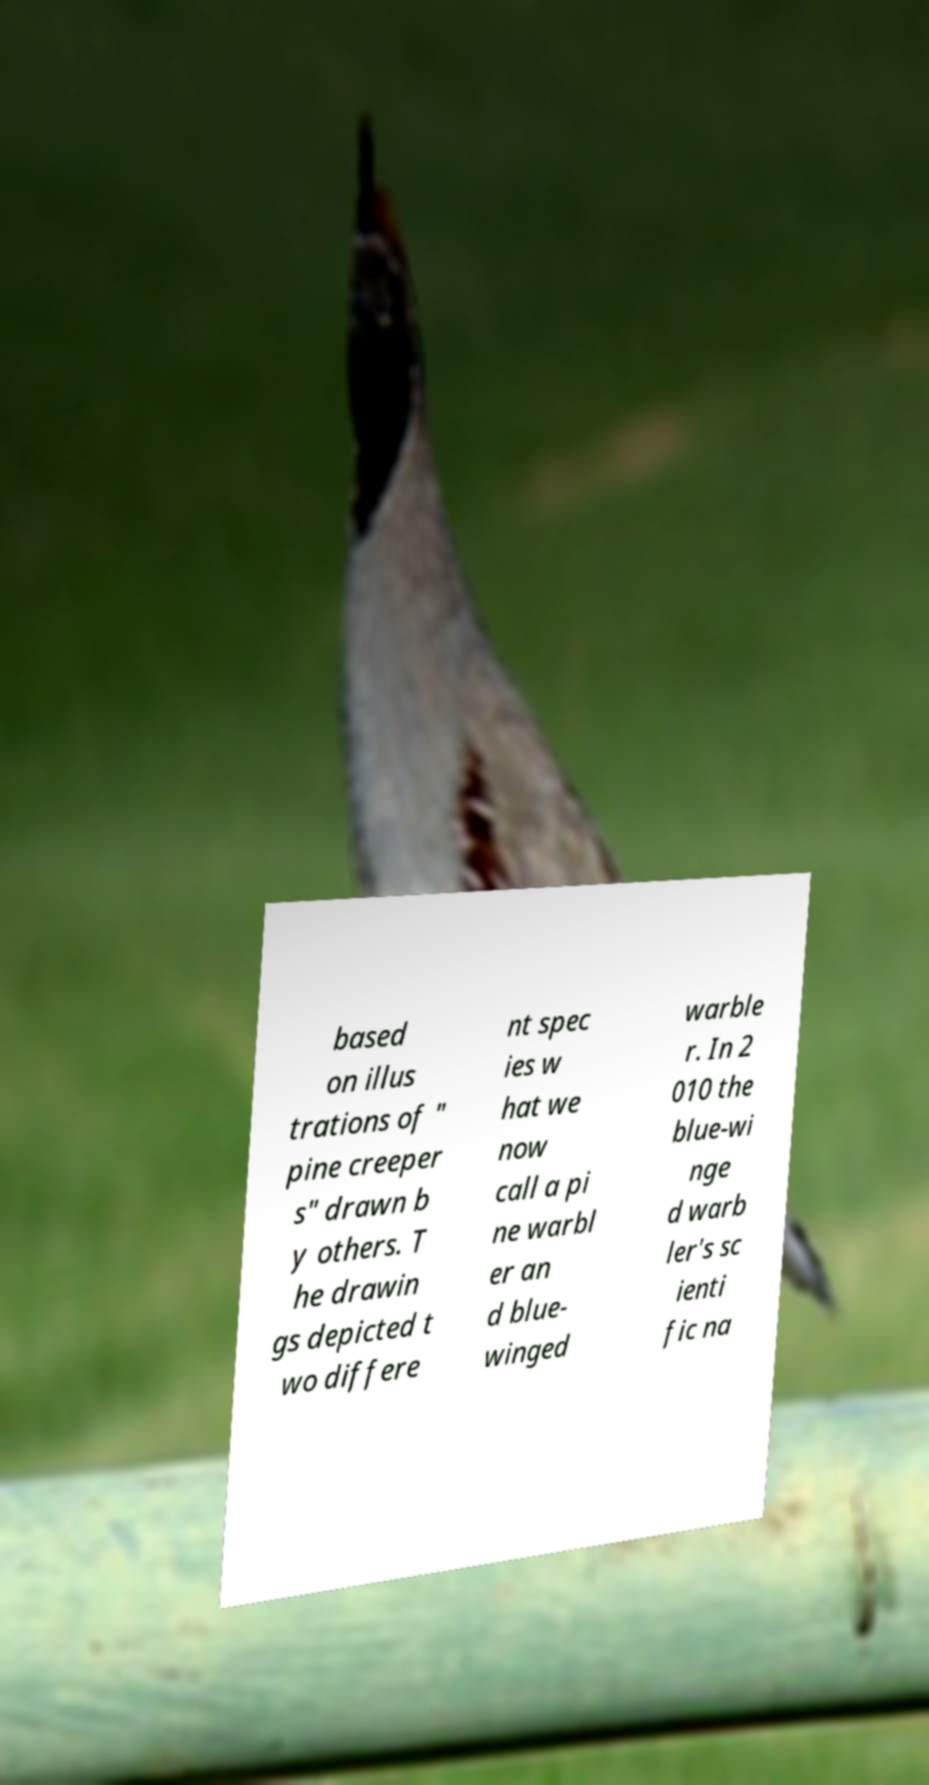Please identify and transcribe the text found in this image. based on illus trations of " pine creeper s" drawn b y others. T he drawin gs depicted t wo differe nt spec ies w hat we now call a pi ne warbl er an d blue- winged warble r. In 2 010 the blue-wi nge d warb ler's sc ienti fic na 